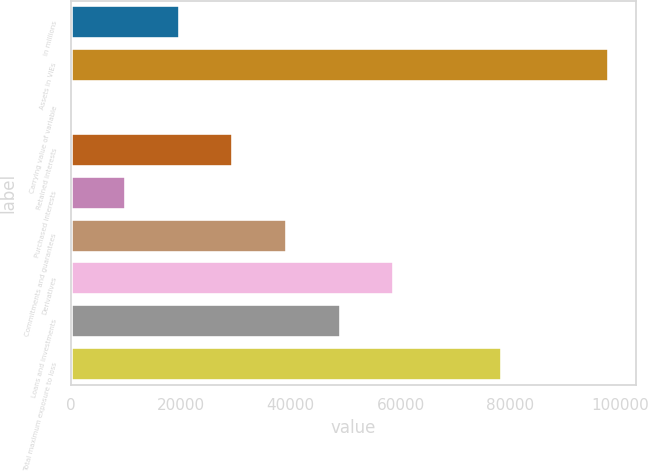<chart> <loc_0><loc_0><loc_500><loc_500><bar_chart><fcel>in millions<fcel>Assets in VIEs<fcel>Carrying value of variable<fcel>Retained interests<fcel>Purchased interests<fcel>Commitments and guarantees<fcel>Derivatives<fcel>Loans and investments<fcel>Total maximum exposure to loss<nl><fcel>19763.6<fcel>97962<fcel>214<fcel>29538.4<fcel>9988.8<fcel>39313.2<fcel>58862.8<fcel>49088<fcel>78412.4<nl></chart> 